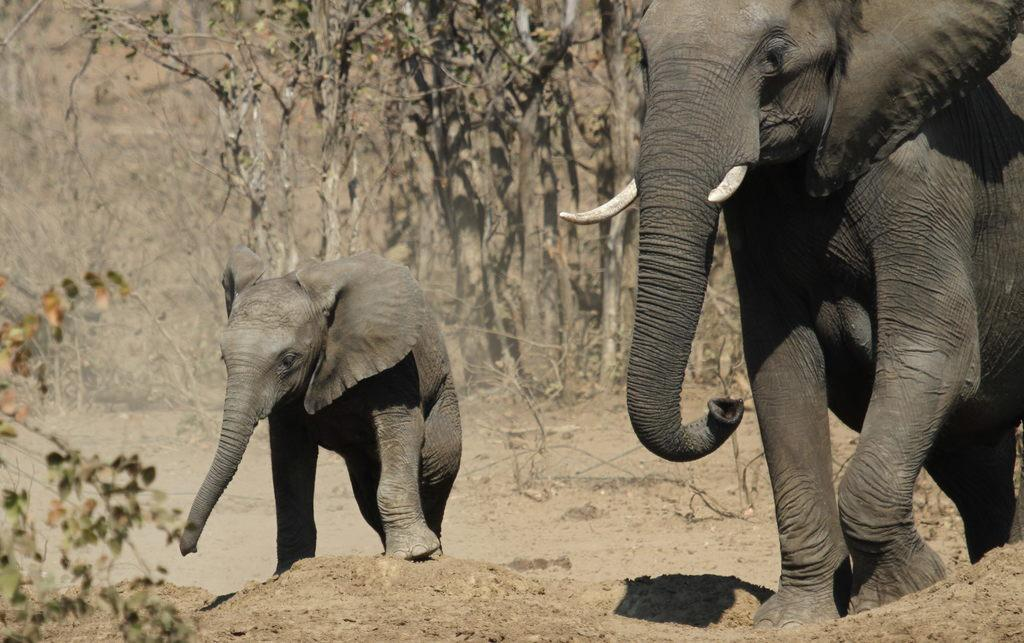How many elephants are present in the image? There are two elephants in the image. What are the elephants doing in the image? The elephants are walking on the ground. Can you describe any other objects or elements in the image? Yes, there is a plant in the left bottom corner of the image, and there are trees in the background. What type of ring can be seen on the elephant's trunk in the image? There is no ring present on the elephant's trunk in the image. What material is the steel fence surrounding the elephants made of in the image? There is no steel fence surrounding the elephants in the image. 